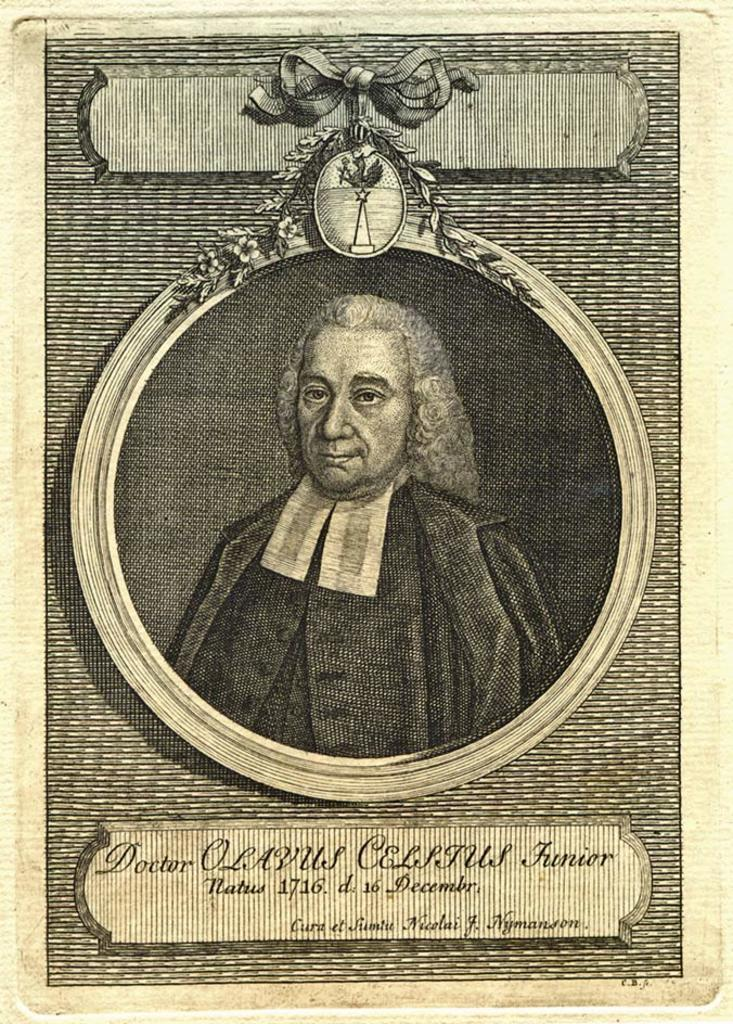What is present on the poster in the image? The image contains a poster with images and text on it. Can you describe the main image on the poster? There is an image of a man in the middle of the poster. What is the man holding in the image on the poster? The man is holding a bow in the image. What type of meal is being prepared in the image? There is no meal being prepared in the image; it contains a poster with an image of a man holding a bow. Can you hear the horn in the image? There is no horn present in the image; it contains a poster with an image of a man holding a bow. 